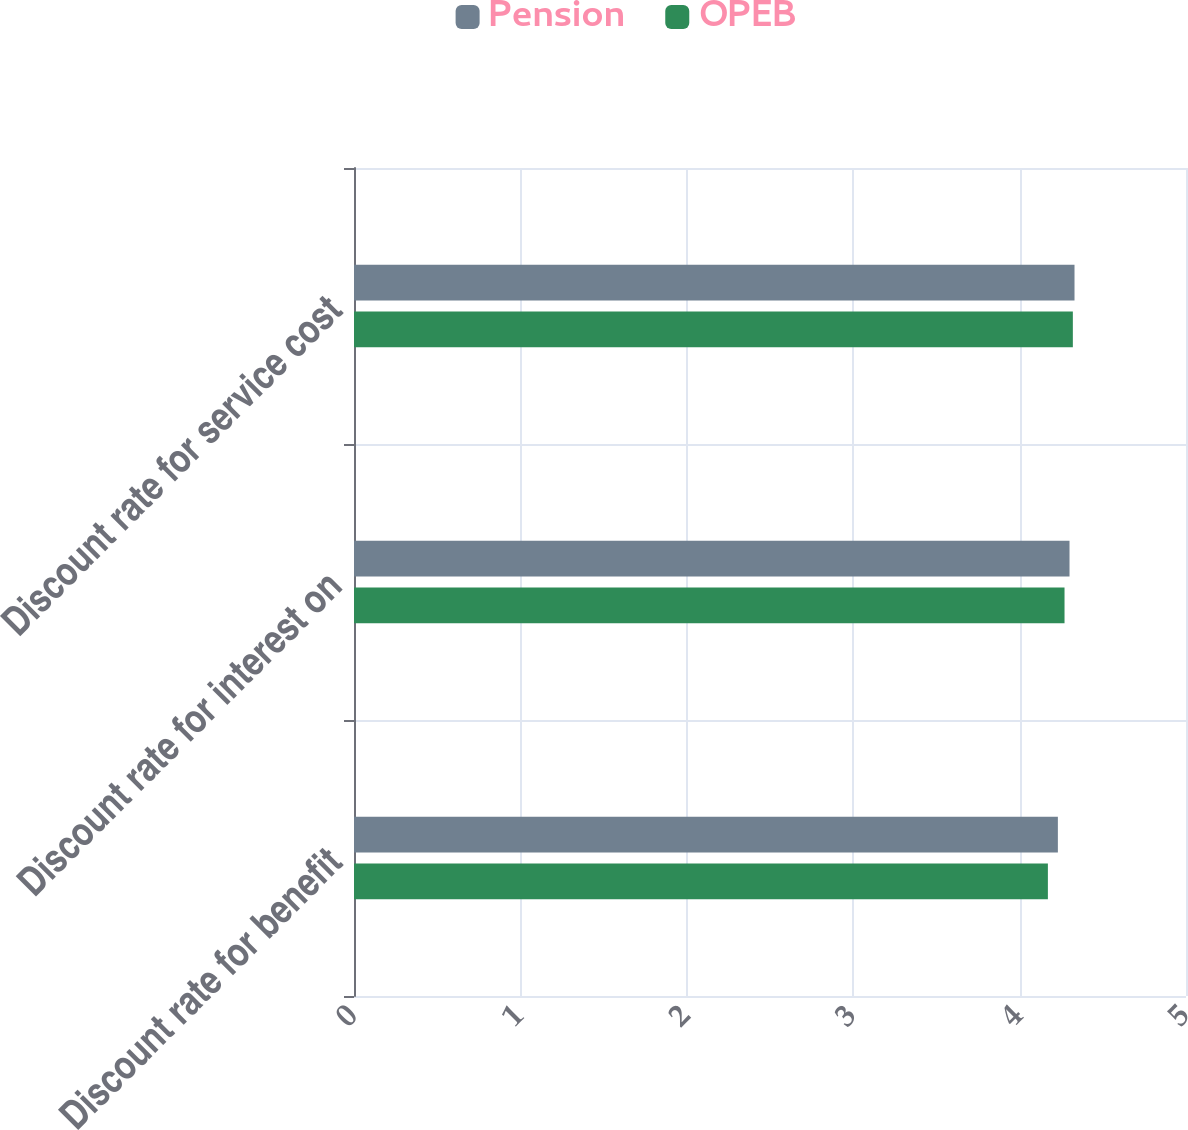Convert chart. <chart><loc_0><loc_0><loc_500><loc_500><stacked_bar_chart><ecel><fcel>Discount rate for benefit<fcel>Discount rate for interest on<fcel>Discount rate for service cost<nl><fcel>Pension<fcel>4.23<fcel>4.3<fcel>4.33<nl><fcel>OPEB<fcel>4.17<fcel>4.27<fcel>4.32<nl></chart> 